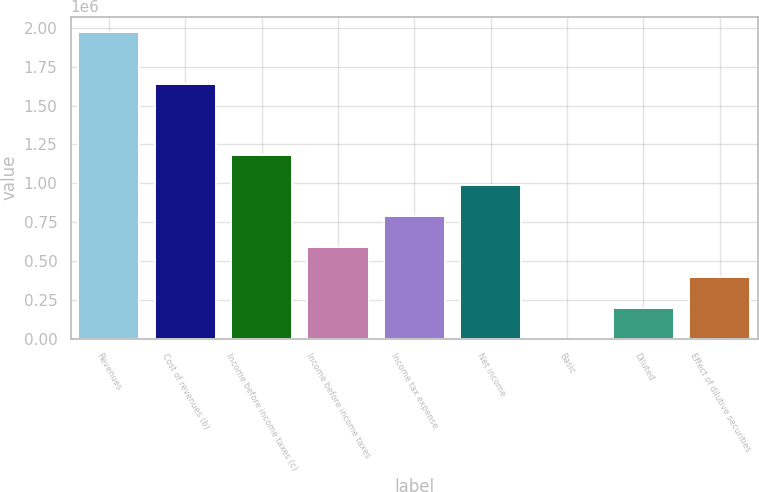Convert chart. <chart><loc_0><loc_0><loc_500><loc_500><bar_chart><fcel>Revenues<fcel>Cost of revenues (b)<fcel>Income before income taxes (c)<fcel>Income before income taxes<fcel>Income tax expense<fcel>Net income<fcel>Basic<fcel>Diluted<fcel>Effect of dilutive securities<nl><fcel>1.97357e+06<fcel>1.63754e+06<fcel>1.18414e+06<fcel>592072<fcel>789429<fcel>986786<fcel>0.32<fcel>197357<fcel>394714<nl></chart> 